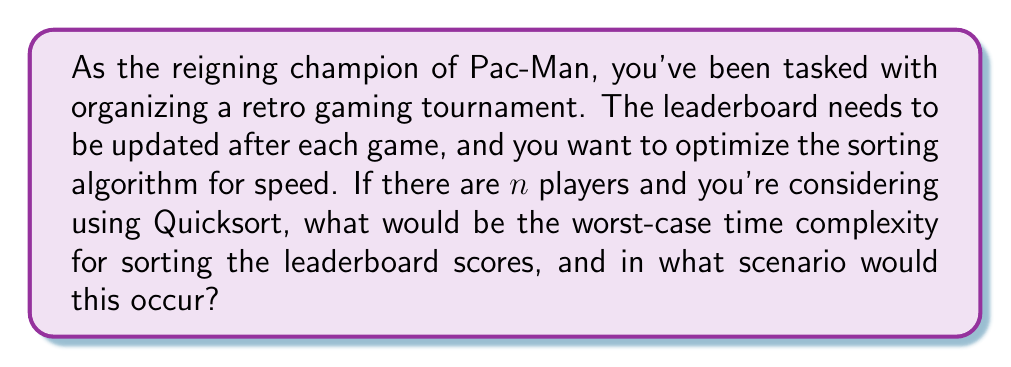Solve this math problem. Let's break this down step-by-step:

1) Quicksort is a comparison-based sorting algorithm that uses a divide-and-conquer strategy.

2) In the average case, Quicksort has a time complexity of $O(n \log n)$, where $n$ is the number of elements to be sorted.

3) However, the worst-case scenario for Quicksort occurs when the pivot element chosen at each step is either the smallest or largest element in the array. This can happen if:
   a) The array is already sorted (ascending or descending)
   b) All elements in the array are the same

4) In this worst-case scenario, the partitioning is maximally unbalanced at each step. Instead of dividing the problem into two roughly equal subproblems, it creates one subproblem with $n-1$ elements and one with 0 elements.

5) This leads to a recurrence relation:
   $T(n) = T(n-1) + O(n)$

6) Solving this recurrence relation yields a time complexity of $O(n^2)$.

7) In the context of our leaderboard, this worst-case would occur if:
   a) All players have the same score (unlikely in a real tournament)
   b) The scores are already perfectly sorted (either highest to lowest or lowest to highest)

8) For an old-school arcade tournament, the latter scenario is more likely. If players are added to the leaderboard as they finish, and most finish with scores lower than the current leaders, you could end up with a nearly sorted list, triggering Quicksort's worst-case behavior.
Answer: The worst-case time complexity for Quicksort on the leaderboard would be $O(n^2)$, occurring when the scores are already sorted or nearly sorted. 